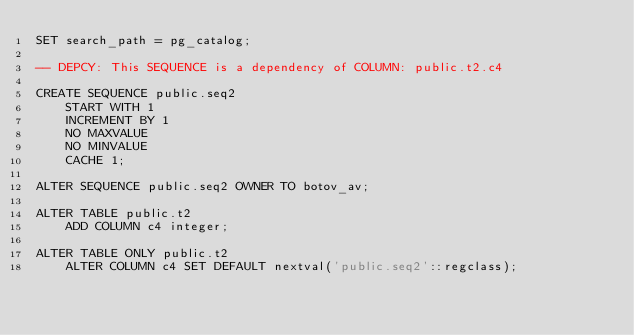Convert code to text. <code><loc_0><loc_0><loc_500><loc_500><_SQL_>SET search_path = pg_catalog;

-- DEPCY: This SEQUENCE is a dependency of COLUMN: public.t2.c4

CREATE SEQUENCE public.seq2
	START WITH 1
	INCREMENT BY 1
	NO MAXVALUE
	NO MINVALUE
	CACHE 1;

ALTER SEQUENCE public.seq2 OWNER TO botov_av;

ALTER TABLE public.t2
	ADD COLUMN c4 integer;

ALTER TABLE ONLY public.t2
	ALTER COLUMN c4 SET DEFAULT nextval('public.seq2'::regclass);</code> 